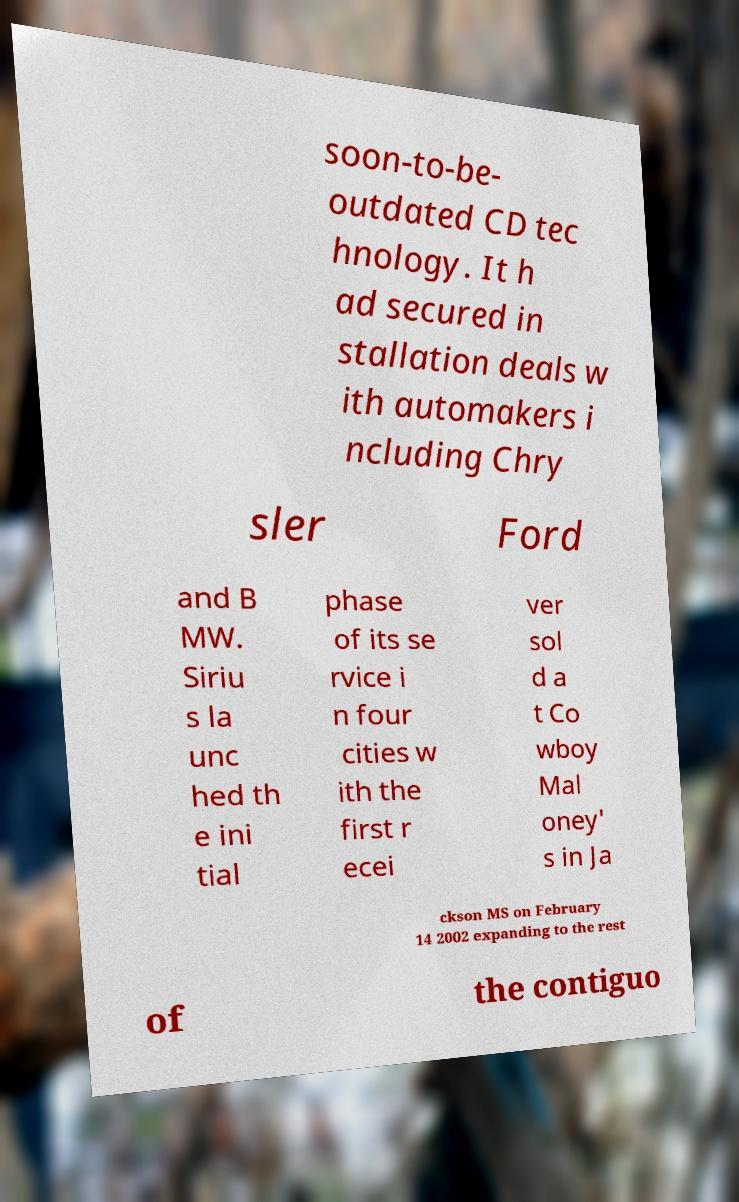There's text embedded in this image that I need extracted. Can you transcribe it verbatim? soon-to-be- outdated CD tec hnology. It h ad secured in stallation deals w ith automakers i ncluding Chry sler Ford and B MW. Siriu s la unc hed th e ini tial phase of its se rvice i n four cities w ith the first r ecei ver sol d a t Co wboy Mal oney' s in Ja ckson MS on February 14 2002 expanding to the rest of the contiguo 